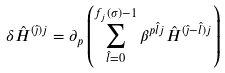<formula> <loc_0><loc_0><loc_500><loc_500>\delta { \hat { H } } ^ { ( { \hat { \jmath } } ) j } = \partial _ { p } \left ( \sum _ { { \hat { l } } = 0 } ^ { f _ { j } ( \sigma ) - 1 } \beta ^ { p { \hat { l } } j } { \hat { H } } ^ { ( { \hat { \jmath } } - { \hat { l } } ) j } \right )</formula> 